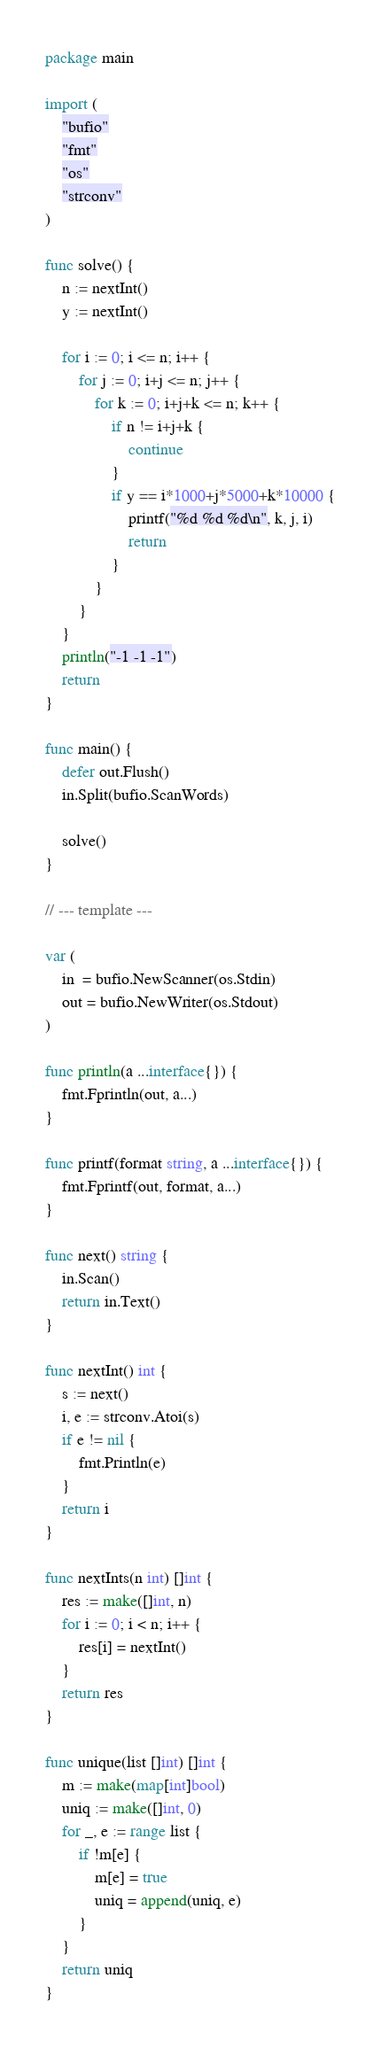<code> <loc_0><loc_0><loc_500><loc_500><_Go_>package main

import (
	"bufio"
	"fmt"
	"os"
	"strconv"
)

func solve() {
	n := nextInt()
	y := nextInt()

	for i := 0; i <= n; i++ {
		for j := 0; i+j <= n; j++ {
			for k := 0; i+j+k <= n; k++ {
				if n != i+j+k {
					continue
				}
				if y == i*1000+j*5000+k*10000 {
					printf("%d %d %d\n", k, j, i)
					return
				}
			}
		}
	}
	println("-1 -1 -1")
	return
}

func main() {
	defer out.Flush()
	in.Split(bufio.ScanWords)

	solve()
}

// --- template ---

var (
	in  = bufio.NewScanner(os.Stdin)
	out = bufio.NewWriter(os.Stdout)
)

func println(a ...interface{}) {
	fmt.Fprintln(out, a...)
}

func printf(format string, a ...interface{}) {
	fmt.Fprintf(out, format, a...)
}

func next() string {
	in.Scan()
	return in.Text()
}

func nextInt() int {
	s := next()
	i, e := strconv.Atoi(s)
	if e != nil {
		fmt.Println(e)
	}
	return i
}

func nextInts(n int) []int {
	res := make([]int, n)
	for i := 0; i < n; i++ {
		res[i] = nextInt()
	}
	return res
}

func unique(list []int) []int {
	m := make(map[int]bool)
	uniq := make([]int, 0)
	for _, e := range list {
		if !m[e] {
			m[e] = true
			uniq = append(uniq, e)
		}
	}
	return uniq
}
</code> 